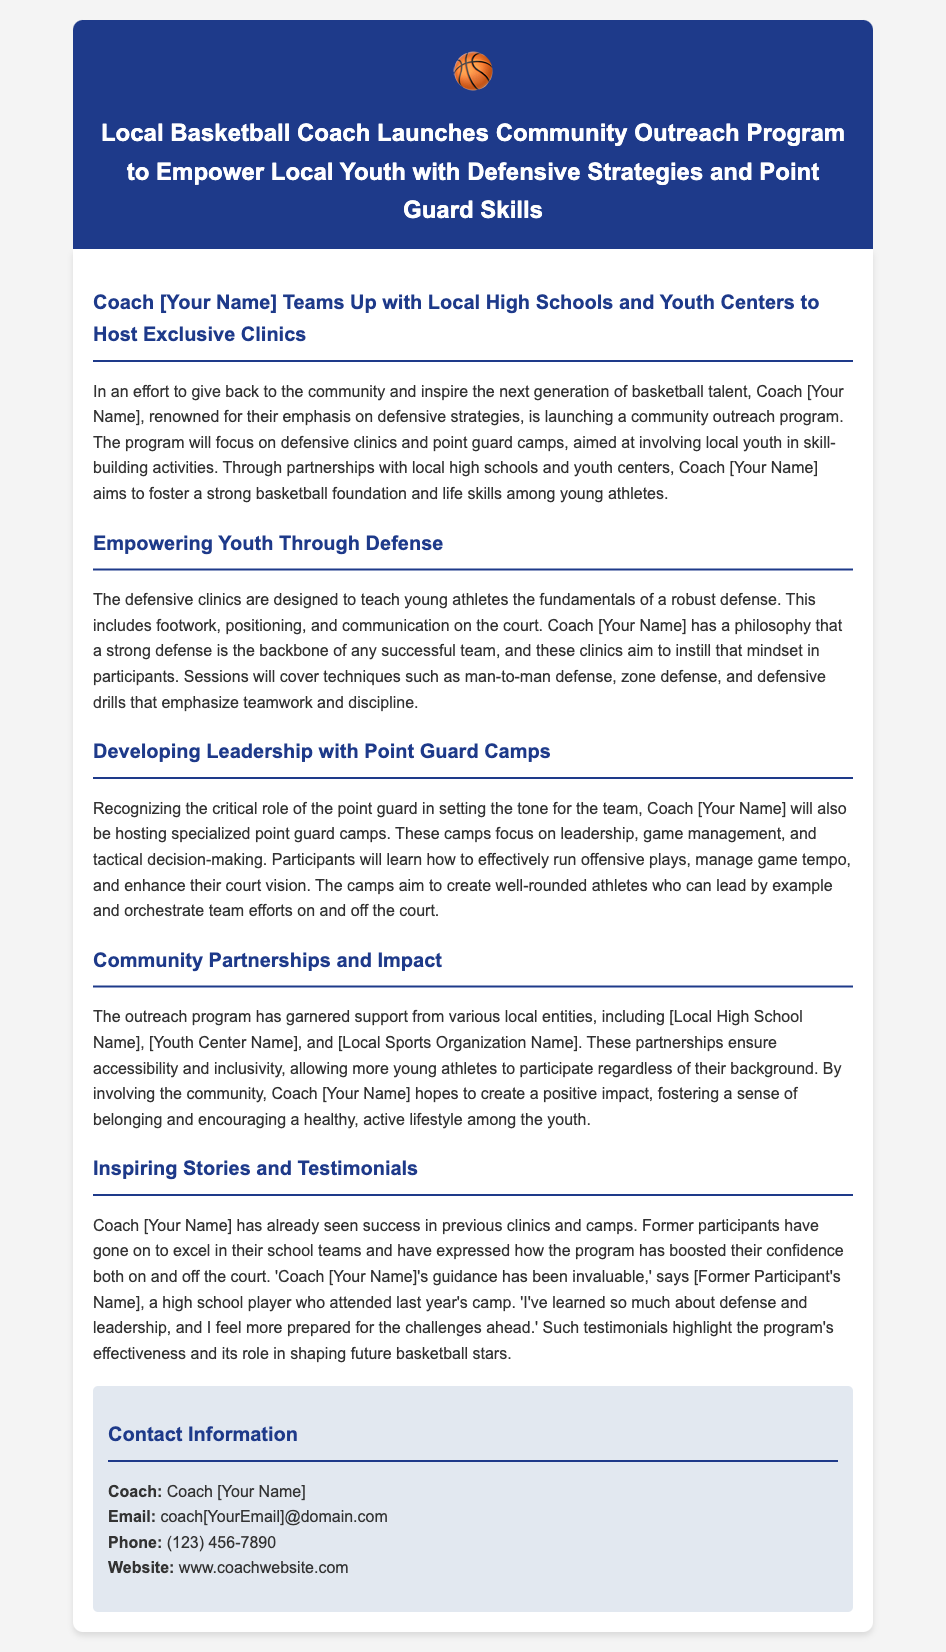what is the primary focus of the community outreach program? The program focuses on defensive clinics and point guard camps aimed at involving local youth.
Answer: defensive clinics and point guard camps who is teaming up with Coach [Your Name] for the outreach program? Coach [Your Name] is partnering with local high schools and youth centers.
Answer: local high schools and youth centers what are the key skills taught in the defensive clinics? The clinics teach fundamentals including footwork, positioning, and communication on the court.
Answer: footwork, positioning, and communication how do point guard camps contribute to athlete development? The camps focus on leadership, game management, and tactical decision-making for point guards.
Answer: leadership, game management, and tactical decision-making which local entities support the outreach program? The program has support from various local entities including [Local High School Name], [Youth Center Name], and [Local Sports Organization Name].
Answer: [Local High School Name], [Youth Center Name], and [Local Sports Organization Name] what underlying philosophy drives the defensive clinics? Coach [Your Name] believes that a strong defense is the backbone of any successful team.
Answer: strong defense is the backbone of any successful team who shared a testimonial about the program? A high school player named [Former Participant's Name] provided a testimonial about the program.
Answer: [Former Participant's Name] what is Coach [Your Name]'s contact email? The email for Coach [Your Name] is coach[YourEmail]@domain.com.
Answer: coach[YourEmail]@domain.com what is the expected impact of the program on participants? The program aims to foster a sense of belonging and encourage a healthy, active lifestyle among the youth.
Answer: foster a sense of belonging and encourage a healthy, active lifestyle 